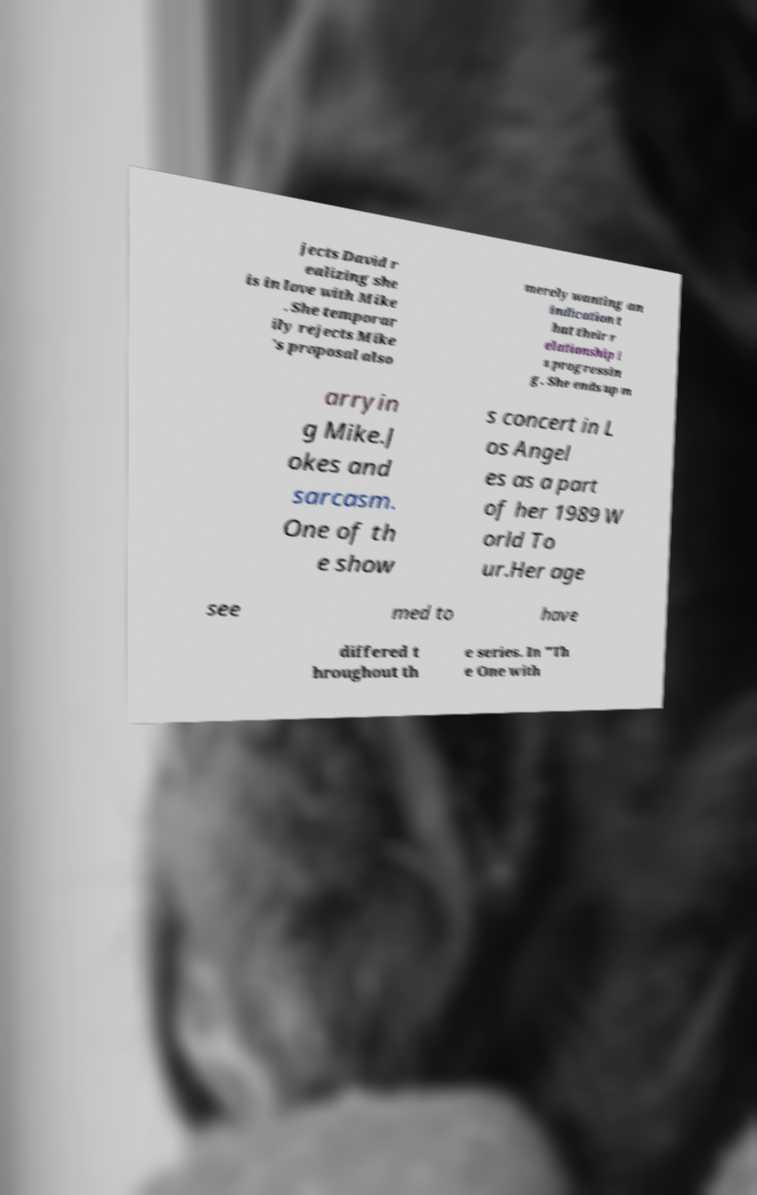Please identify and transcribe the text found in this image. jects David r ealizing she is in love with Mike . She temporar ily rejects Mike 's proposal also merely wanting an indication t hat their r elationship i s progressin g. She ends up m arryin g Mike.J okes and sarcasm. One of th e show s concert in L os Angel es as a part of her 1989 W orld To ur.Her age see med to have differed t hroughout th e series. In "Th e One with 